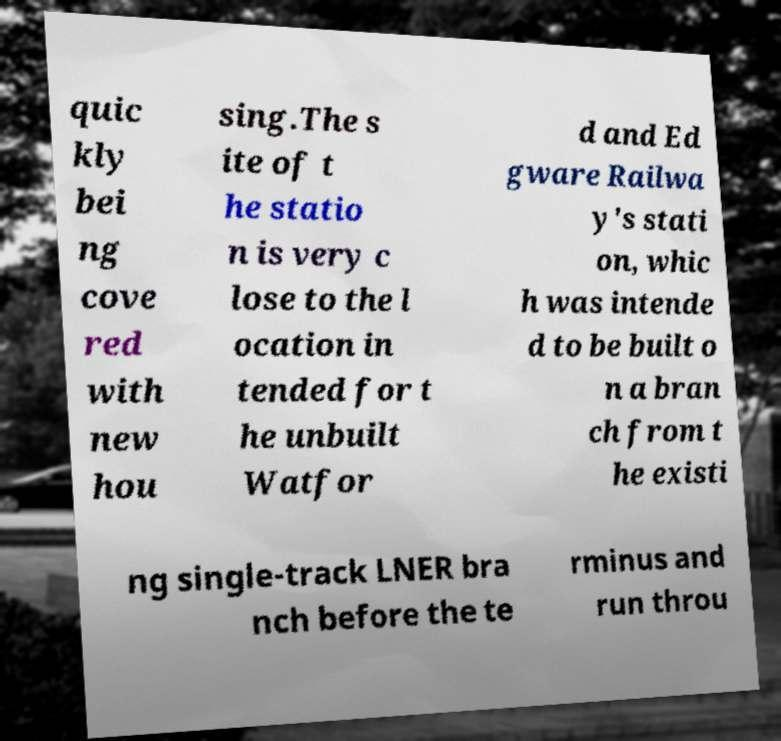There's text embedded in this image that I need extracted. Can you transcribe it verbatim? quic kly bei ng cove red with new hou sing.The s ite of t he statio n is very c lose to the l ocation in tended for t he unbuilt Watfor d and Ed gware Railwa y's stati on, whic h was intende d to be built o n a bran ch from t he existi ng single-track LNER bra nch before the te rminus and run throu 